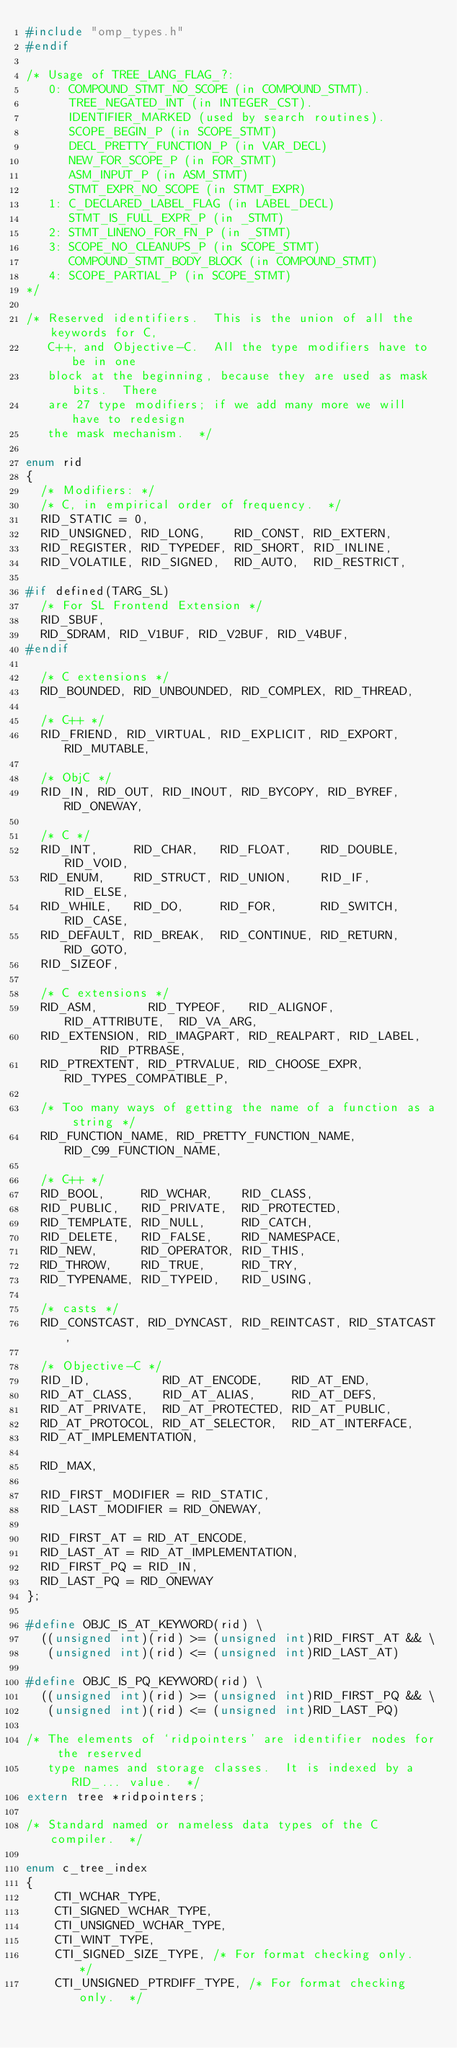<code> <loc_0><loc_0><loc_500><loc_500><_C_>#include "omp_types.h"
#endif

/* Usage of TREE_LANG_FLAG_?:
   0: COMPOUND_STMT_NO_SCOPE (in COMPOUND_STMT).
      TREE_NEGATED_INT (in INTEGER_CST).
      IDENTIFIER_MARKED (used by search routines).
      SCOPE_BEGIN_P (in SCOPE_STMT)
      DECL_PRETTY_FUNCTION_P (in VAR_DECL)
      NEW_FOR_SCOPE_P (in FOR_STMT)
      ASM_INPUT_P (in ASM_STMT)
      STMT_EXPR_NO_SCOPE (in STMT_EXPR)
   1: C_DECLARED_LABEL_FLAG (in LABEL_DECL)
      STMT_IS_FULL_EXPR_P (in _STMT)
   2: STMT_LINENO_FOR_FN_P (in _STMT)
   3: SCOPE_NO_CLEANUPS_P (in SCOPE_STMT)
      COMPOUND_STMT_BODY_BLOCK (in COMPOUND_STMT)
   4: SCOPE_PARTIAL_P (in SCOPE_STMT)
*/

/* Reserved identifiers.  This is the union of all the keywords for C,
   C++, and Objective-C.  All the type modifiers have to be in one
   block at the beginning, because they are used as mask bits.  There
   are 27 type modifiers; if we add many more we will have to redesign
   the mask mechanism.  */

enum rid
{
  /* Modifiers: */
  /* C, in empirical order of frequency.  */
  RID_STATIC = 0,
  RID_UNSIGNED, RID_LONG,    RID_CONST, RID_EXTERN,
  RID_REGISTER, RID_TYPEDEF, RID_SHORT, RID_INLINE,
  RID_VOLATILE, RID_SIGNED,  RID_AUTO,  RID_RESTRICT,

#if defined(TARG_SL)
  /* For SL Frontend Extension */
  RID_SBUF,
  RID_SDRAM, RID_V1BUF, RID_V2BUF, RID_V4BUF, 
#endif

  /* C extensions */
  RID_BOUNDED, RID_UNBOUNDED, RID_COMPLEX, RID_THREAD,

  /* C++ */
  RID_FRIEND, RID_VIRTUAL, RID_EXPLICIT, RID_EXPORT, RID_MUTABLE,

  /* ObjC */
  RID_IN, RID_OUT, RID_INOUT, RID_BYCOPY, RID_BYREF, RID_ONEWAY,

  /* C */
  RID_INT,     RID_CHAR,   RID_FLOAT,    RID_DOUBLE, RID_VOID,
  RID_ENUM,    RID_STRUCT, RID_UNION,    RID_IF,     RID_ELSE,
  RID_WHILE,   RID_DO,     RID_FOR,      RID_SWITCH, RID_CASE,
  RID_DEFAULT, RID_BREAK,  RID_CONTINUE, RID_RETURN, RID_GOTO,
  RID_SIZEOF,

  /* C extensions */
  RID_ASM,       RID_TYPEOF,   RID_ALIGNOF,  RID_ATTRIBUTE,  RID_VA_ARG,
  RID_EXTENSION, RID_IMAGPART, RID_REALPART, RID_LABEL,      RID_PTRBASE,
  RID_PTREXTENT, RID_PTRVALUE, RID_CHOOSE_EXPR, RID_TYPES_COMPATIBLE_P,

  /* Too many ways of getting the name of a function as a string */
  RID_FUNCTION_NAME, RID_PRETTY_FUNCTION_NAME, RID_C99_FUNCTION_NAME,

  /* C++ */
  RID_BOOL,     RID_WCHAR,    RID_CLASS,
  RID_PUBLIC,   RID_PRIVATE,  RID_PROTECTED,
  RID_TEMPLATE, RID_NULL,     RID_CATCH,
  RID_DELETE,   RID_FALSE,    RID_NAMESPACE,
  RID_NEW,      RID_OPERATOR, RID_THIS,
  RID_THROW,    RID_TRUE,     RID_TRY,
  RID_TYPENAME, RID_TYPEID,   RID_USING,

  /* casts */
  RID_CONSTCAST, RID_DYNCAST, RID_REINTCAST, RID_STATCAST,

  /* Objective-C */
  RID_ID,          RID_AT_ENCODE,    RID_AT_END,
  RID_AT_CLASS,    RID_AT_ALIAS,     RID_AT_DEFS,
  RID_AT_PRIVATE,  RID_AT_PROTECTED, RID_AT_PUBLIC,
  RID_AT_PROTOCOL, RID_AT_SELECTOR,  RID_AT_INTERFACE,
  RID_AT_IMPLEMENTATION,

  RID_MAX,

  RID_FIRST_MODIFIER = RID_STATIC,
  RID_LAST_MODIFIER = RID_ONEWAY,

  RID_FIRST_AT = RID_AT_ENCODE,
  RID_LAST_AT = RID_AT_IMPLEMENTATION,
  RID_FIRST_PQ = RID_IN,
  RID_LAST_PQ = RID_ONEWAY
};

#define OBJC_IS_AT_KEYWORD(rid) \
  ((unsigned int)(rid) >= (unsigned int)RID_FIRST_AT && \
   (unsigned int)(rid) <= (unsigned int)RID_LAST_AT)

#define OBJC_IS_PQ_KEYWORD(rid) \
  ((unsigned int)(rid) >= (unsigned int)RID_FIRST_PQ && \
   (unsigned int)(rid) <= (unsigned int)RID_LAST_PQ)

/* The elements of `ridpointers' are identifier nodes for the reserved
   type names and storage classes.  It is indexed by a RID_... value.  */
extern tree *ridpointers;

/* Standard named or nameless data types of the C compiler.  */

enum c_tree_index
{
    CTI_WCHAR_TYPE,
    CTI_SIGNED_WCHAR_TYPE,
    CTI_UNSIGNED_WCHAR_TYPE,
    CTI_WINT_TYPE,
    CTI_SIGNED_SIZE_TYPE, /* For format checking only.  */
    CTI_UNSIGNED_PTRDIFF_TYPE, /* For format checking only.  */</code> 